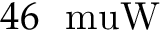<formula> <loc_0><loc_0><loc_500><loc_500>4 6 \ m u W</formula> 